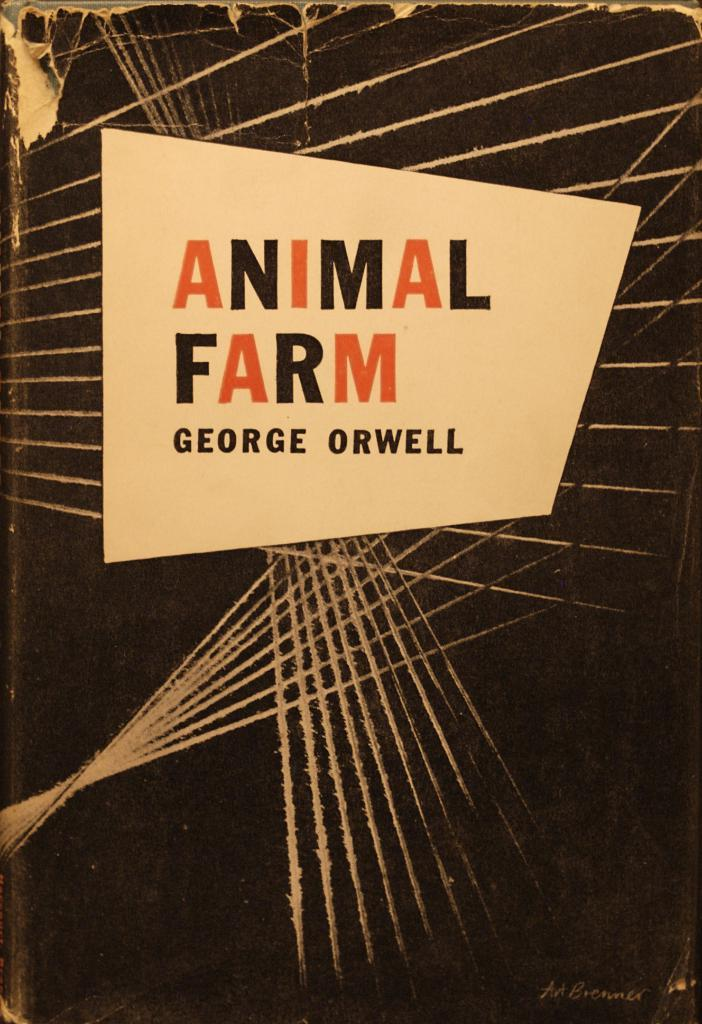Provide a one-sentence caption for the provided image. An old book called Animal farm by George Orwell. 